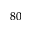<formula> <loc_0><loc_0><loc_500><loc_500>^ { 8 0 }</formula> 